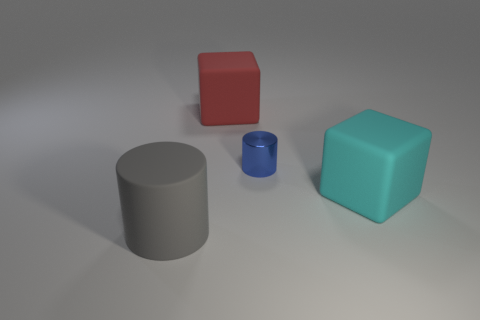Is there any other thing that is the same material as the small object?
Your answer should be compact. No. There is a cylinder on the right side of the cube left of the matte block in front of the blue thing; how big is it?
Offer a very short reply. Small. There is a large object right of the block behind the large cyan block; what shape is it?
Give a very brief answer. Cube. What is the color of the big matte object that is to the left of the tiny blue object and in front of the large red cube?
Your response must be concise. Gray. Are there any large cyan blocks made of the same material as the big gray thing?
Your answer should be very brief. Yes. The metal cylinder is what size?
Offer a terse response. Small. What size is the cylinder behind the cyan rubber cube that is in front of the red rubber cube?
Offer a very short reply. Small. What material is the blue object that is the same shape as the gray matte object?
Your answer should be very brief. Metal. What number of matte blocks are there?
Ensure brevity in your answer.  2. There is a cylinder behind the large gray matte cylinder on the left side of the cylinder behind the large gray thing; what color is it?
Provide a succinct answer. Blue. 